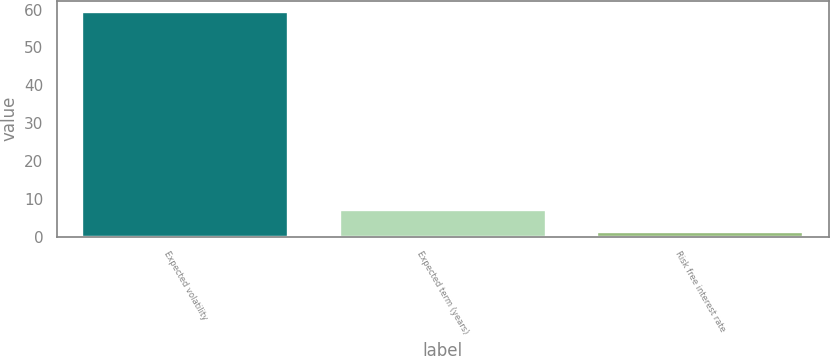Convert chart to OTSL. <chart><loc_0><loc_0><loc_500><loc_500><bar_chart><fcel>Expected volatility<fcel>Expected term (years)<fcel>Risk free interest rate<nl><fcel>59.39<fcel>7<fcel>1.18<nl></chart> 